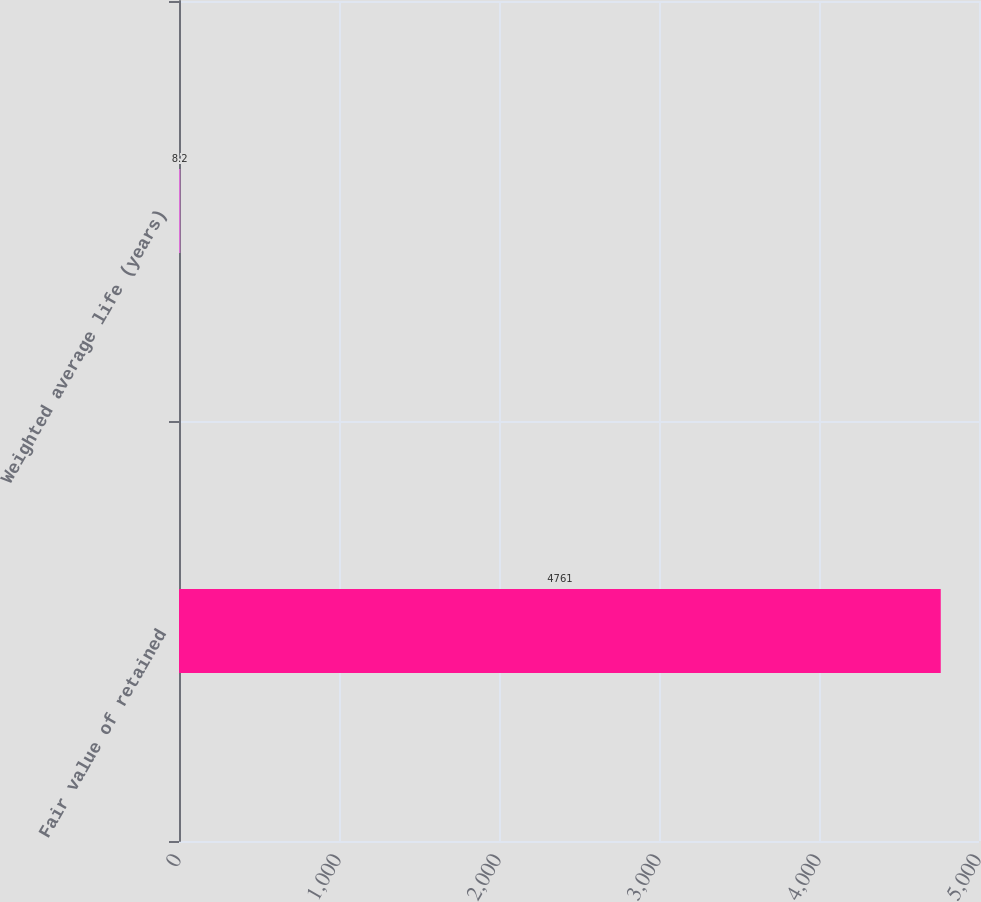<chart> <loc_0><loc_0><loc_500><loc_500><bar_chart><fcel>Fair value of retained<fcel>Weighted average life (years)<nl><fcel>4761<fcel>8.2<nl></chart> 